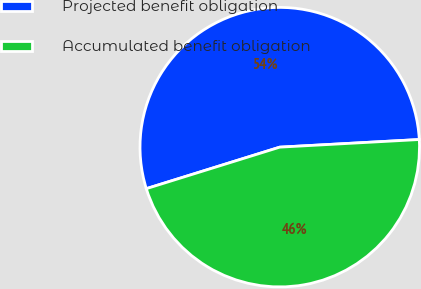Convert chart. <chart><loc_0><loc_0><loc_500><loc_500><pie_chart><fcel>Projected benefit obligation<fcel>Accumulated benefit obligation<nl><fcel>53.93%<fcel>46.07%<nl></chart> 